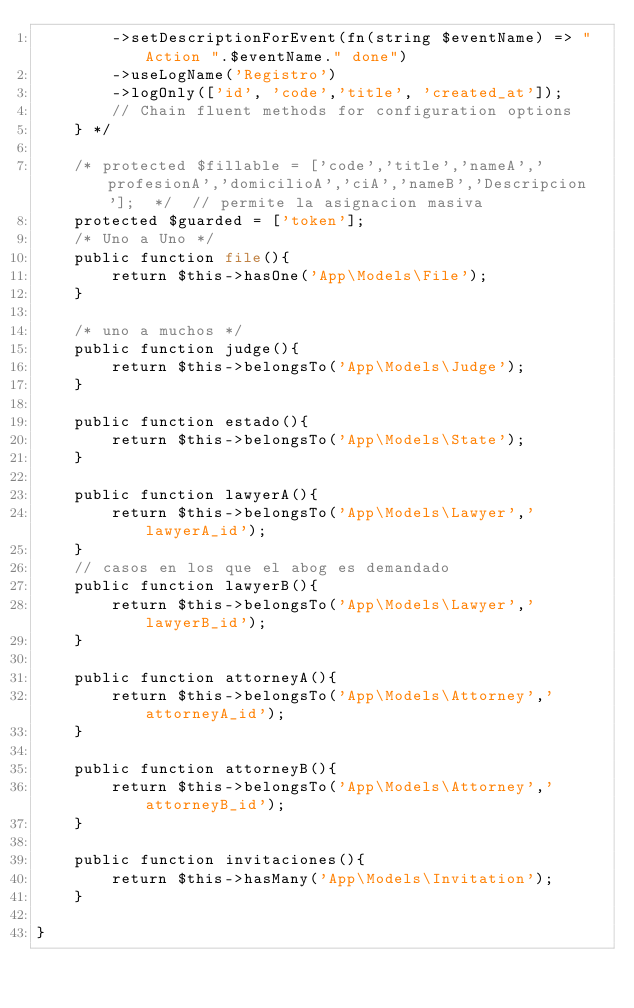<code> <loc_0><loc_0><loc_500><loc_500><_PHP_>        ->setDescriptionForEvent(fn(string $eventName) => "Action ".$eventName." done")
        ->useLogName('Registro')
        ->logOnly(['id', 'code','title', 'created_at']);
        // Chain fluent methods for configuration options
    } */

    /* protected $fillable = ['code','title','nameA','profesionA','domicilioA','ciA','nameB','Descripcion'];  */  // permite la asignacion masiva 
    protected $guarded = ['token'];
    /* Uno a Uno */
    public function file(){
        return $this->hasOne('App\Models\File');
    }

    /* uno a muchos */
    public function judge(){
        return $this->belongsTo('App\Models\Judge');
    }

    public function estado(){
        return $this->belongsTo('App\Models\State');
    }

    public function lawyerA(){
        return $this->belongsTo('App\Models\Lawyer','lawyerA_id');
    }
    // casos en los que el abog es demandado
    public function lawyerB(){
        return $this->belongsTo('App\Models\Lawyer','lawyerB_id');
    }

    public function attorneyA(){
        return $this->belongsTo('App\Models\Attorney','attorneyA_id');
    }
                       
    public function attorneyB(){
        return $this->belongsTo('App\Models\Attorney','attorneyB_id');
    }

    public function invitaciones(){
        return $this->hasMany('App\Models\Invitation');
    }
    
}
</code> 